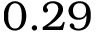<formula> <loc_0><loc_0><loc_500><loc_500>0 . 2 9</formula> 